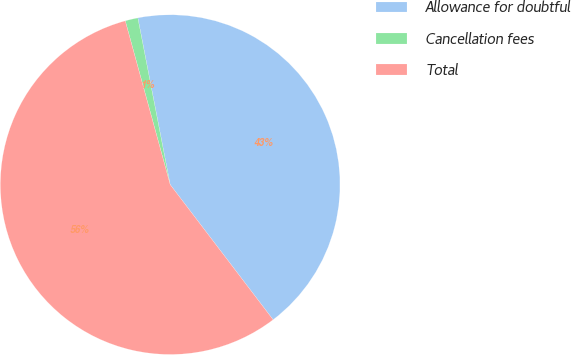Convert chart. <chart><loc_0><loc_0><loc_500><loc_500><pie_chart><fcel>Allowance for doubtful<fcel>Cancellation fees<fcel>Total<nl><fcel>42.69%<fcel>1.21%<fcel>56.1%<nl></chart> 